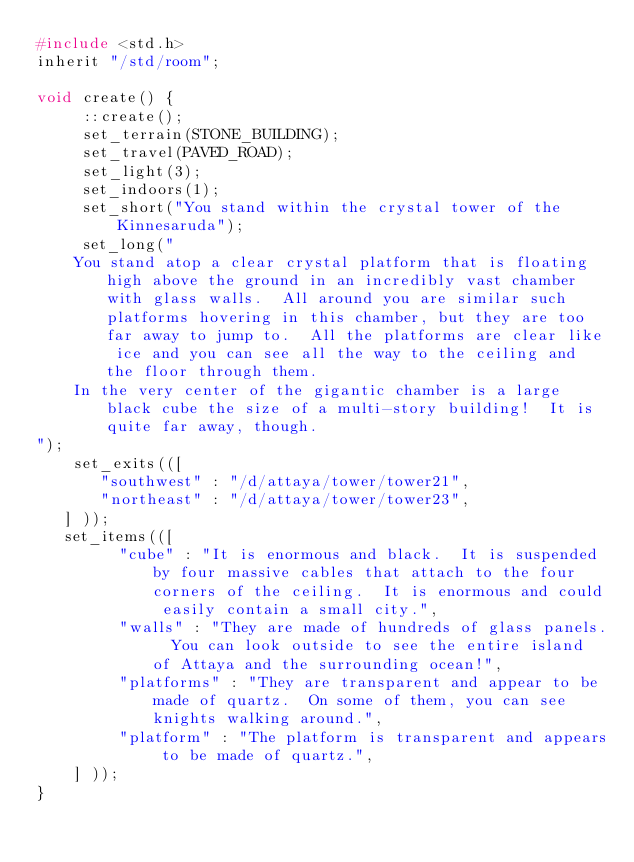Convert code to text. <code><loc_0><loc_0><loc_500><loc_500><_C_>#include <std.h>
inherit "/std/room";

void create() {
     ::create();
     set_terrain(STONE_BUILDING);
     set_travel(PAVED_ROAD);
     set_light(3);
     set_indoors(1);
     set_short("You stand within the crystal tower of the Kinnesaruda");
     set_long("
    You stand atop a clear crystal platform that is floating high above the ground in an incredibly vast chamber with glass walls.  All around you are similar such platforms hovering in this chamber, but they are too far away to jump to.  All the platforms are clear like ice and you can see all the way to the ceiling and the floor through them.  
    In the very center of the gigantic chamber is a large black cube the size of a multi-story building!  It is quite far away, though.
");
    set_exits(([
       "southwest" : "/d/attaya/tower/tower21",
       "northeast" : "/d/attaya/tower/tower23",
   ] ));
   set_items(([
         "cube" : "It is enormous and black.  It is suspended by four massive cables that attach to the four corners of the ceiling.  It is enormous and could easily contain a small city.",
         "walls" : "They are made of hundreds of glass panels.  You can look outside to see the entire island of Attaya and the surrounding ocean!",
         "platforms" : "They are transparent and appear to be made of quartz.  On some of them, you can see knights walking around.",
         "platform" : "The platform is transparent and appears to be made of quartz.",
    ] ));
}

</code> 